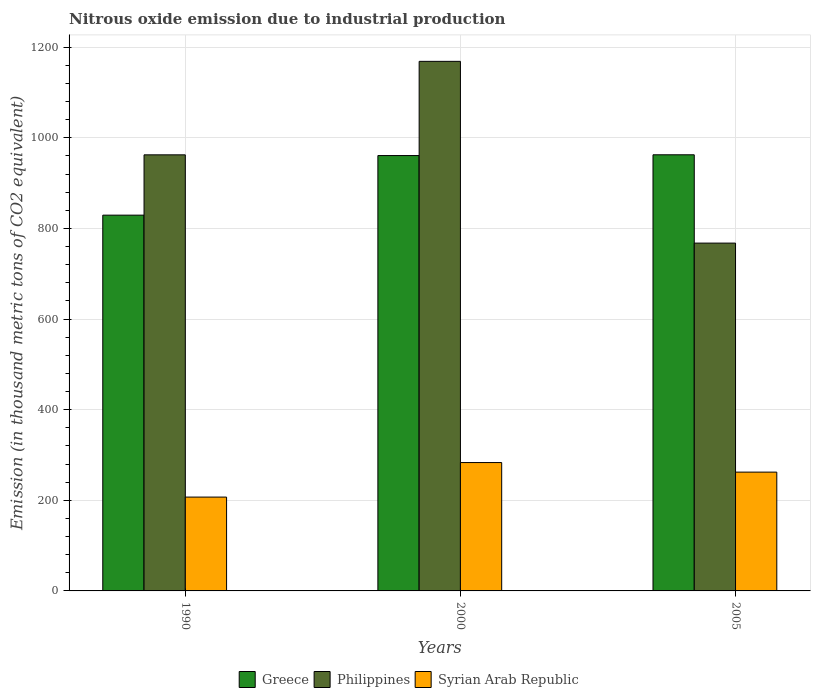How many different coloured bars are there?
Keep it short and to the point. 3. How many groups of bars are there?
Offer a terse response. 3. Are the number of bars per tick equal to the number of legend labels?
Offer a terse response. Yes. How many bars are there on the 1st tick from the left?
Your answer should be very brief. 3. In how many cases, is the number of bars for a given year not equal to the number of legend labels?
Give a very brief answer. 0. What is the amount of nitrous oxide emitted in Greece in 1990?
Provide a short and direct response. 829.3. Across all years, what is the maximum amount of nitrous oxide emitted in Greece?
Make the answer very short. 962.5. Across all years, what is the minimum amount of nitrous oxide emitted in Greece?
Ensure brevity in your answer.  829.3. In which year was the amount of nitrous oxide emitted in Syrian Arab Republic minimum?
Offer a very short reply. 1990. What is the total amount of nitrous oxide emitted in Philippines in the graph?
Your answer should be very brief. 2898.7. What is the difference between the amount of nitrous oxide emitted in Greece in 1990 and that in 2005?
Give a very brief answer. -133.2. What is the difference between the amount of nitrous oxide emitted in Philippines in 2000 and the amount of nitrous oxide emitted in Greece in 1990?
Your answer should be compact. 339.4. What is the average amount of nitrous oxide emitted in Greece per year?
Make the answer very short. 917.53. In the year 2000, what is the difference between the amount of nitrous oxide emitted in Philippines and amount of nitrous oxide emitted in Greece?
Your response must be concise. 207.9. In how many years, is the amount of nitrous oxide emitted in Philippines greater than 1160 thousand metric tons?
Keep it short and to the point. 1. What is the ratio of the amount of nitrous oxide emitted in Philippines in 1990 to that in 2000?
Make the answer very short. 0.82. Is the difference between the amount of nitrous oxide emitted in Philippines in 2000 and 2005 greater than the difference between the amount of nitrous oxide emitted in Greece in 2000 and 2005?
Keep it short and to the point. Yes. What is the difference between the highest and the second highest amount of nitrous oxide emitted in Greece?
Keep it short and to the point. 1.7. What is the difference between the highest and the lowest amount of nitrous oxide emitted in Greece?
Your answer should be compact. 133.2. What does the 1st bar from the left in 2000 represents?
Your response must be concise. Greece. Is it the case that in every year, the sum of the amount of nitrous oxide emitted in Philippines and amount of nitrous oxide emitted in Greece is greater than the amount of nitrous oxide emitted in Syrian Arab Republic?
Your response must be concise. Yes. How many bars are there?
Offer a very short reply. 9. How many years are there in the graph?
Offer a terse response. 3. What is the difference between two consecutive major ticks on the Y-axis?
Offer a very short reply. 200. Does the graph contain any zero values?
Offer a very short reply. No. Does the graph contain grids?
Provide a short and direct response. Yes. Where does the legend appear in the graph?
Ensure brevity in your answer.  Bottom center. How many legend labels are there?
Your answer should be very brief. 3. How are the legend labels stacked?
Offer a terse response. Horizontal. What is the title of the graph?
Keep it short and to the point. Nitrous oxide emission due to industrial production. What is the label or title of the Y-axis?
Your answer should be very brief. Emission (in thousand metric tons of CO2 equivalent). What is the Emission (in thousand metric tons of CO2 equivalent) in Greece in 1990?
Provide a succinct answer. 829.3. What is the Emission (in thousand metric tons of CO2 equivalent) of Philippines in 1990?
Provide a succinct answer. 962.4. What is the Emission (in thousand metric tons of CO2 equivalent) of Syrian Arab Republic in 1990?
Your response must be concise. 207.1. What is the Emission (in thousand metric tons of CO2 equivalent) of Greece in 2000?
Ensure brevity in your answer.  960.8. What is the Emission (in thousand metric tons of CO2 equivalent) in Philippines in 2000?
Keep it short and to the point. 1168.7. What is the Emission (in thousand metric tons of CO2 equivalent) of Syrian Arab Republic in 2000?
Make the answer very short. 283.3. What is the Emission (in thousand metric tons of CO2 equivalent) of Greece in 2005?
Make the answer very short. 962.5. What is the Emission (in thousand metric tons of CO2 equivalent) of Philippines in 2005?
Your response must be concise. 767.6. What is the Emission (in thousand metric tons of CO2 equivalent) of Syrian Arab Republic in 2005?
Offer a terse response. 262.2. Across all years, what is the maximum Emission (in thousand metric tons of CO2 equivalent) of Greece?
Your answer should be very brief. 962.5. Across all years, what is the maximum Emission (in thousand metric tons of CO2 equivalent) of Philippines?
Your answer should be compact. 1168.7. Across all years, what is the maximum Emission (in thousand metric tons of CO2 equivalent) in Syrian Arab Republic?
Ensure brevity in your answer.  283.3. Across all years, what is the minimum Emission (in thousand metric tons of CO2 equivalent) in Greece?
Offer a terse response. 829.3. Across all years, what is the minimum Emission (in thousand metric tons of CO2 equivalent) of Philippines?
Offer a very short reply. 767.6. Across all years, what is the minimum Emission (in thousand metric tons of CO2 equivalent) of Syrian Arab Republic?
Your response must be concise. 207.1. What is the total Emission (in thousand metric tons of CO2 equivalent) of Greece in the graph?
Your response must be concise. 2752.6. What is the total Emission (in thousand metric tons of CO2 equivalent) in Philippines in the graph?
Offer a terse response. 2898.7. What is the total Emission (in thousand metric tons of CO2 equivalent) of Syrian Arab Republic in the graph?
Give a very brief answer. 752.6. What is the difference between the Emission (in thousand metric tons of CO2 equivalent) of Greece in 1990 and that in 2000?
Provide a short and direct response. -131.5. What is the difference between the Emission (in thousand metric tons of CO2 equivalent) in Philippines in 1990 and that in 2000?
Provide a succinct answer. -206.3. What is the difference between the Emission (in thousand metric tons of CO2 equivalent) in Syrian Arab Republic in 1990 and that in 2000?
Provide a succinct answer. -76.2. What is the difference between the Emission (in thousand metric tons of CO2 equivalent) of Greece in 1990 and that in 2005?
Give a very brief answer. -133.2. What is the difference between the Emission (in thousand metric tons of CO2 equivalent) in Philippines in 1990 and that in 2005?
Give a very brief answer. 194.8. What is the difference between the Emission (in thousand metric tons of CO2 equivalent) in Syrian Arab Republic in 1990 and that in 2005?
Your response must be concise. -55.1. What is the difference between the Emission (in thousand metric tons of CO2 equivalent) in Philippines in 2000 and that in 2005?
Your answer should be very brief. 401.1. What is the difference between the Emission (in thousand metric tons of CO2 equivalent) in Syrian Arab Republic in 2000 and that in 2005?
Make the answer very short. 21.1. What is the difference between the Emission (in thousand metric tons of CO2 equivalent) in Greece in 1990 and the Emission (in thousand metric tons of CO2 equivalent) in Philippines in 2000?
Your answer should be very brief. -339.4. What is the difference between the Emission (in thousand metric tons of CO2 equivalent) in Greece in 1990 and the Emission (in thousand metric tons of CO2 equivalent) in Syrian Arab Republic in 2000?
Your answer should be very brief. 546. What is the difference between the Emission (in thousand metric tons of CO2 equivalent) of Philippines in 1990 and the Emission (in thousand metric tons of CO2 equivalent) of Syrian Arab Republic in 2000?
Ensure brevity in your answer.  679.1. What is the difference between the Emission (in thousand metric tons of CO2 equivalent) in Greece in 1990 and the Emission (in thousand metric tons of CO2 equivalent) in Philippines in 2005?
Offer a very short reply. 61.7. What is the difference between the Emission (in thousand metric tons of CO2 equivalent) of Greece in 1990 and the Emission (in thousand metric tons of CO2 equivalent) of Syrian Arab Republic in 2005?
Make the answer very short. 567.1. What is the difference between the Emission (in thousand metric tons of CO2 equivalent) in Philippines in 1990 and the Emission (in thousand metric tons of CO2 equivalent) in Syrian Arab Republic in 2005?
Offer a very short reply. 700.2. What is the difference between the Emission (in thousand metric tons of CO2 equivalent) of Greece in 2000 and the Emission (in thousand metric tons of CO2 equivalent) of Philippines in 2005?
Offer a terse response. 193.2. What is the difference between the Emission (in thousand metric tons of CO2 equivalent) in Greece in 2000 and the Emission (in thousand metric tons of CO2 equivalent) in Syrian Arab Republic in 2005?
Offer a terse response. 698.6. What is the difference between the Emission (in thousand metric tons of CO2 equivalent) in Philippines in 2000 and the Emission (in thousand metric tons of CO2 equivalent) in Syrian Arab Republic in 2005?
Your answer should be very brief. 906.5. What is the average Emission (in thousand metric tons of CO2 equivalent) of Greece per year?
Ensure brevity in your answer.  917.53. What is the average Emission (in thousand metric tons of CO2 equivalent) in Philippines per year?
Your answer should be very brief. 966.23. What is the average Emission (in thousand metric tons of CO2 equivalent) of Syrian Arab Republic per year?
Provide a short and direct response. 250.87. In the year 1990, what is the difference between the Emission (in thousand metric tons of CO2 equivalent) in Greece and Emission (in thousand metric tons of CO2 equivalent) in Philippines?
Provide a short and direct response. -133.1. In the year 1990, what is the difference between the Emission (in thousand metric tons of CO2 equivalent) of Greece and Emission (in thousand metric tons of CO2 equivalent) of Syrian Arab Republic?
Offer a terse response. 622.2. In the year 1990, what is the difference between the Emission (in thousand metric tons of CO2 equivalent) in Philippines and Emission (in thousand metric tons of CO2 equivalent) in Syrian Arab Republic?
Your response must be concise. 755.3. In the year 2000, what is the difference between the Emission (in thousand metric tons of CO2 equivalent) of Greece and Emission (in thousand metric tons of CO2 equivalent) of Philippines?
Provide a succinct answer. -207.9. In the year 2000, what is the difference between the Emission (in thousand metric tons of CO2 equivalent) in Greece and Emission (in thousand metric tons of CO2 equivalent) in Syrian Arab Republic?
Provide a succinct answer. 677.5. In the year 2000, what is the difference between the Emission (in thousand metric tons of CO2 equivalent) in Philippines and Emission (in thousand metric tons of CO2 equivalent) in Syrian Arab Republic?
Keep it short and to the point. 885.4. In the year 2005, what is the difference between the Emission (in thousand metric tons of CO2 equivalent) of Greece and Emission (in thousand metric tons of CO2 equivalent) of Philippines?
Your answer should be compact. 194.9. In the year 2005, what is the difference between the Emission (in thousand metric tons of CO2 equivalent) in Greece and Emission (in thousand metric tons of CO2 equivalent) in Syrian Arab Republic?
Offer a very short reply. 700.3. In the year 2005, what is the difference between the Emission (in thousand metric tons of CO2 equivalent) of Philippines and Emission (in thousand metric tons of CO2 equivalent) of Syrian Arab Republic?
Provide a succinct answer. 505.4. What is the ratio of the Emission (in thousand metric tons of CO2 equivalent) of Greece in 1990 to that in 2000?
Offer a terse response. 0.86. What is the ratio of the Emission (in thousand metric tons of CO2 equivalent) in Philippines in 1990 to that in 2000?
Provide a short and direct response. 0.82. What is the ratio of the Emission (in thousand metric tons of CO2 equivalent) of Syrian Arab Republic in 1990 to that in 2000?
Keep it short and to the point. 0.73. What is the ratio of the Emission (in thousand metric tons of CO2 equivalent) of Greece in 1990 to that in 2005?
Ensure brevity in your answer.  0.86. What is the ratio of the Emission (in thousand metric tons of CO2 equivalent) in Philippines in 1990 to that in 2005?
Your answer should be compact. 1.25. What is the ratio of the Emission (in thousand metric tons of CO2 equivalent) in Syrian Arab Republic in 1990 to that in 2005?
Your response must be concise. 0.79. What is the ratio of the Emission (in thousand metric tons of CO2 equivalent) of Greece in 2000 to that in 2005?
Give a very brief answer. 1. What is the ratio of the Emission (in thousand metric tons of CO2 equivalent) in Philippines in 2000 to that in 2005?
Make the answer very short. 1.52. What is the ratio of the Emission (in thousand metric tons of CO2 equivalent) in Syrian Arab Republic in 2000 to that in 2005?
Keep it short and to the point. 1.08. What is the difference between the highest and the second highest Emission (in thousand metric tons of CO2 equivalent) in Greece?
Your answer should be compact. 1.7. What is the difference between the highest and the second highest Emission (in thousand metric tons of CO2 equivalent) in Philippines?
Make the answer very short. 206.3. What is the difference between the highest and the second highest Emission (in thousand metric tons of CO2 equivalent) in Syrian Arab Republic?
Make the answer very short. 21.1. What is the difference between the highest and the lowest Emission (in thousand metric tons of CO2 equivalent) in Greece?
Ensure brevity in your answer.  133.2. What is the difference between the highest and the lowest Emission (in thousand metric tons of CO2 equivalent) in Philippines?
Your response must be concise. 401.1. What is the difference between the highest and the lowest Emission (in thousand metric tons of CO2 equivalent) of Syrian Arab Republic?
Offer a very short reply. 76.2. 